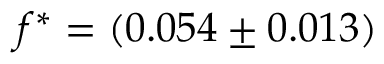Convert formula to latex. <formula><loc_0><loc_0><loc_500><loc_500>f ^ { \ast } = ( 0 . 0 5 4 \pm 0 . 0 1 3 )</formula> 